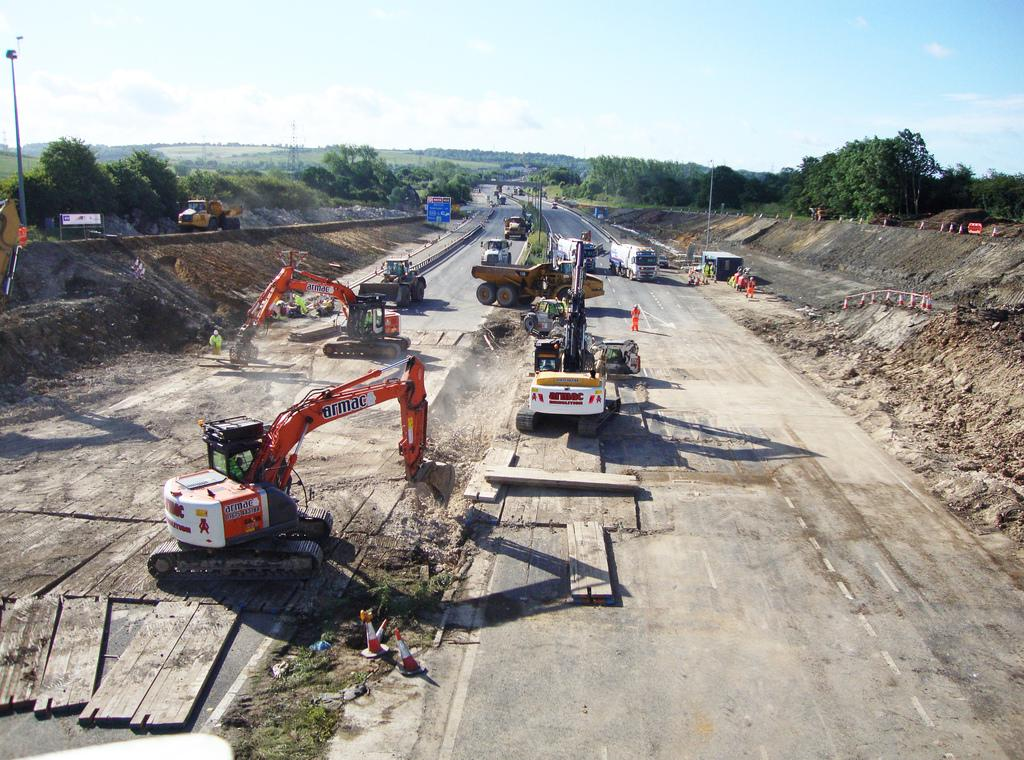<image>
Present a compact description of the photo's key features. An armac excavator is at work doing site work. 